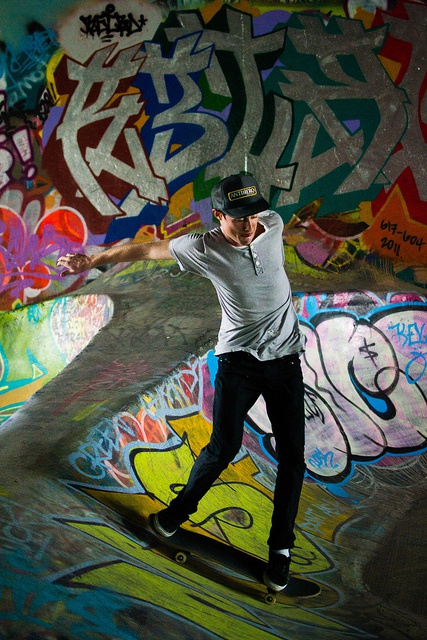Describe the objects in this image and their specific colors. I can see people in darkgreen, black, gray, darkgray, and lightgray tones and skateboard in darkgreen, black, olive, and teal tones in this image. 